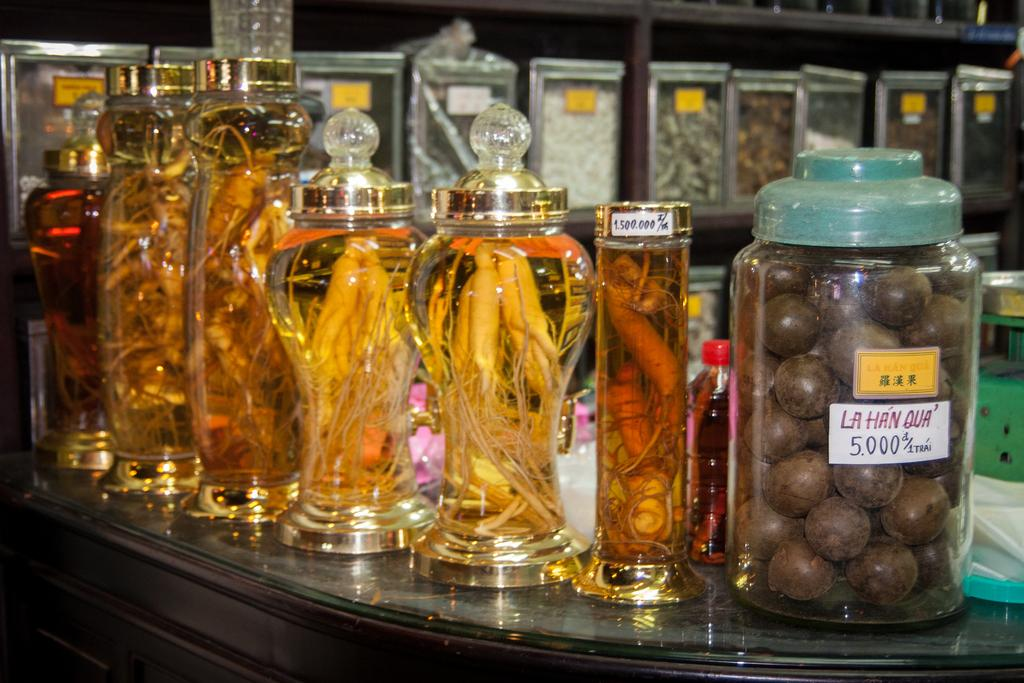What objects are on the table in the image? There are jars on the table in the image. Can you describe the jars in more detail? Unfortunately, the provided facts do not give any additional details about the jars. Are there any other objects on the table besides the jars? The provided facts do not mention any other objects on the table. What type of toy can be seen in the image? There is no toy present in the image; it only features jars on a table. What flavor of soda is in the jars in the image? The provided facts do not mention the contents of the jars, so it is impossible to determine if they contain soda or any other substance. 